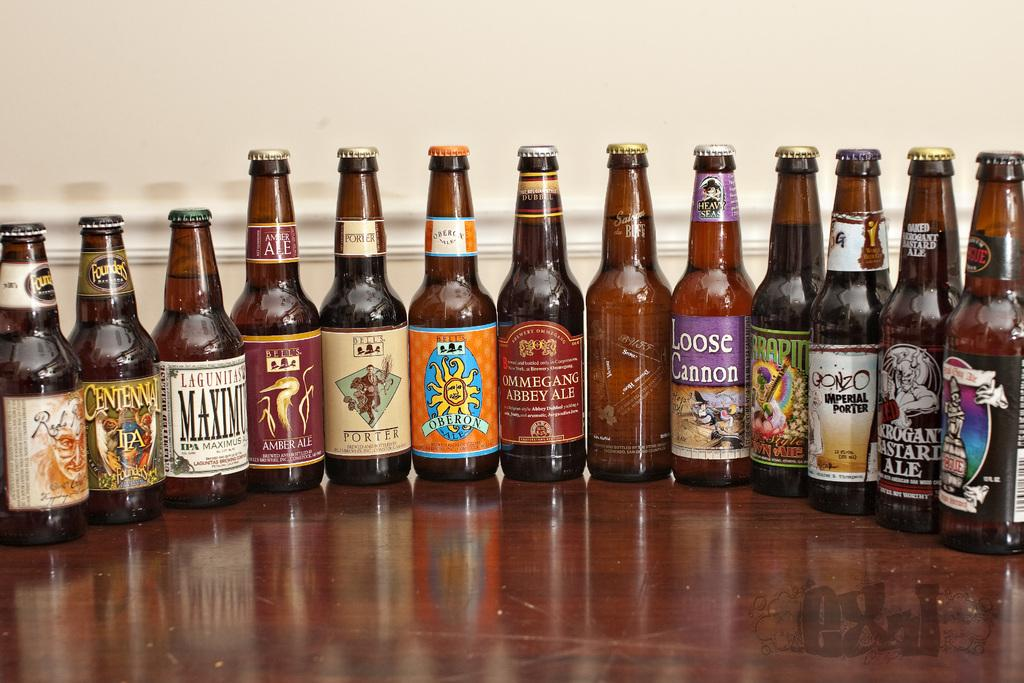What objects are visible in the image? There are bottles in the image. Where are the bottles located? The bottles are on a table. Which actor is performing a kick in the image? There are no actors or kicks present in the image; it only features bottles on a table. 